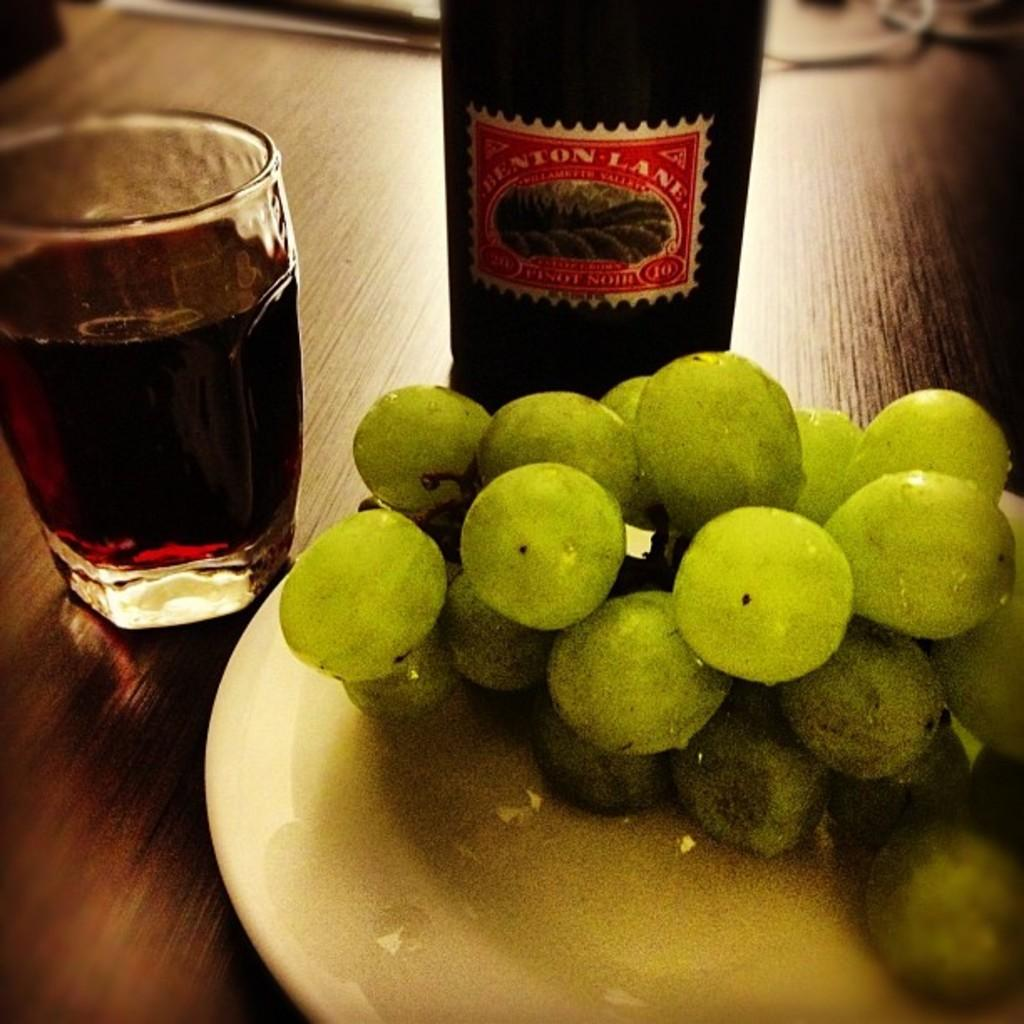What type of food can be seen on a plate in the image? There are fruits on a plate in the image. What is located on a wooden surface in the image? There is a bottle on a wooden surface in the image. What is in a glass that is visible in the image? There is a glass of drink in the image. Can you describe the objects at the top of the image? Unfortunately, the provided facts do not give any information about the objects at the top of the image. What type of jam is being spread on the star in the image? There is no jam or star present in the image. How many fingers can be seen pointing at the glass of drink in the image? There is no mention of fingers in the image, so it is impossible to determine how many fingers might be pointing at the glass of drink. 